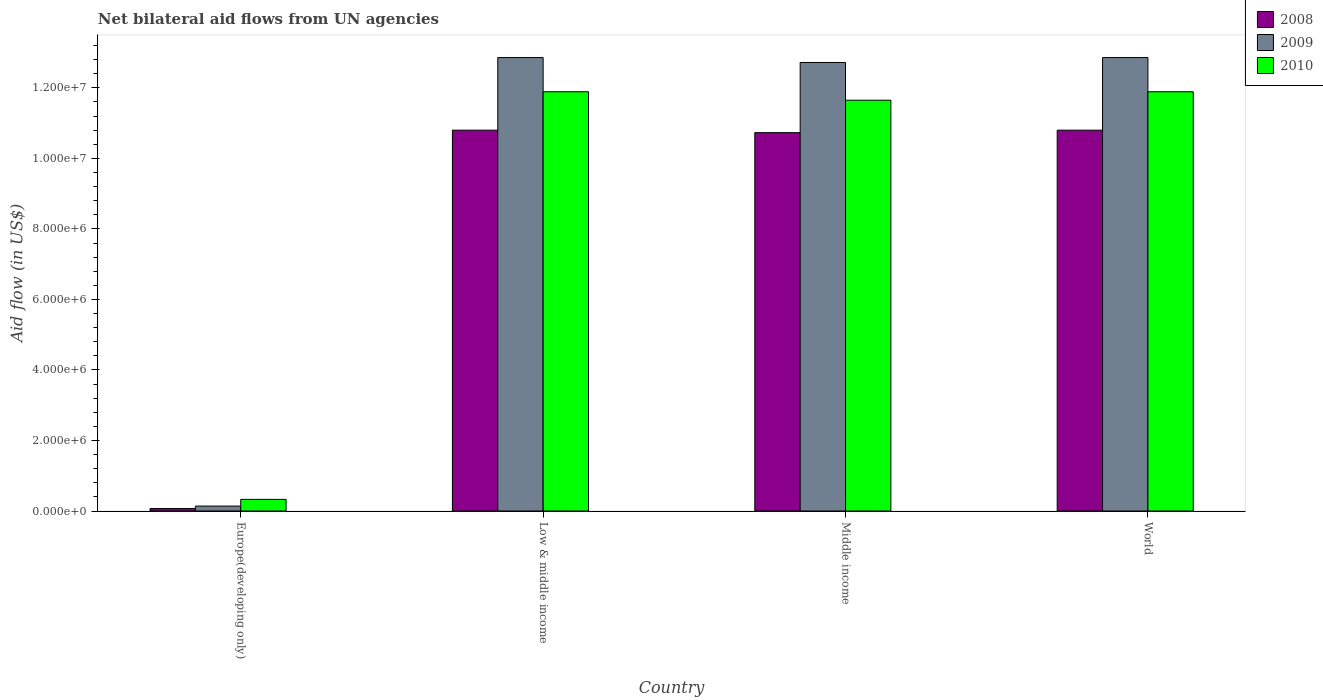How many groups of bars are there?
Your answer should be compact. 4. Are the number of bars per tick equal to the number of legend labels?
Your answer should be very brief. Yes. In how many cases, is the number of bars for a given country not equal to the number of legend labels?
Your response must be concise. 0. What is the net bilateral aid flow in 2009 in Low & middle income?
Your answer should be very brief. 1.29e+07. Across all countries, what is the maximum net bilateral aid flow in 2010?
Give a very brief answer. 1.19e+07. In which country was the net bilateral aid flow in 2008 maximum?
Provide a short and direct response. Low & middle income. In which country was the net bilateral aid flow in 2010 minimum?
Offer a very short reply. Europe(developing only). What is the total net bilateral aid flow in 2008 in the graph?
Your response must be concise. 3.24e+07. What is the difference between the net bilateral aid flow in 2009 in Europe(developing only) and that in Low & middle income?
Your answer should be very brief. -1.27e+07. What is the difference between the net bilateral aid flow in 2009 in World and the net bilateral aid flow in 2008 in Middle income?
Give a very brief answer. 2.13e+06. What is the average net bilateral aid flow in 2009 per country?
Provide a short and direct response. 9.64e+06. What is the difference between the net bilateral aid flow of/in 2009 and net bilateral aid flow of/in 2008 in Low & middle income?
Offer a very short reply. 2.06e+06. What is the ratio of the net bilateral aid flow in 2009 in Middle income to that in World?
Offer a very short reply. 0.99. Is the net bilateral aid flow in 2010 in Low & middle income less than that in Middle income?
Offer a terse response. No. What is the difference between the highest and the second highest net bilateral aid flow in 2008?
Your answer should be very brief. 7.00e+04. What is the difference between the highest and the lowest net bilateral aid flow in 2009?
Your response must be concise. 1.27e+07. In how many countries, is the net bilateral aid flow in 2009 greater than the average net bilateral aid flow in 2009 taken over all countries?
Provide a succinct answer. 3. What does the 2nd bar from the left in Europe(developing only) represents?
Offer a terse response. 2009. What does the 2nd bar from the right in Low & middle income represents?
Your response must be concise. 2009. Is it the case that in every country, the sum of the net bilateral aid flow in 2009 and net bilateral aid flow in 2008 is greater than the net bilateral aid flow in 2010?
Your answer should be very brief. No. How many bars are there?
Your answer should be compact. 12. What is the difference between two consecutive major ticks on the Y-axis?
Keep it short and to the point. 2.00e+06. Where does the legend appear in the graph?
Make the answer very short. Top right. How many legend labels are there?
Your answer should be very brief. 3. How are the legend labels stacked?
Provide a short and direct response. Vertical. What is the title of the graph?
Provide a succinct answer. Net bilateral aid flows from UN agencies. Does "1970" appear as one of the legend labels in the graph?
Give a very brief answer. No. What is the label or title of the X-axis?
Your answer should be very brief. Country. What is the label or title of the Y-axis?
Provide a succinct answer. Aid flow (in US$). What is the Aid flow (in US$) of 2008 in Low & middle income?
Offer a very short reply. 1.08e+07. What is the Aid flow (in US$) of 2009 in Low & middle income?
Offer a very short reply. 1.29e+07. What is the Aid flow (in US$) of 2010 in Low & middle income?
Ensure brevity in your answer.  1.19e+07. What is the Aid flow (in US$) of 2008 in Middle income?
Give a very brief answer. 1.07e+07. What is the Aid flow (in US$) in 2009 in Middle income?
Ensure brevity in your answer.  1.27e+07. What is the Aid flow (in US$) of 2010 in Middle income?
Make the answer very short. 1.16e+07. What is the Aid flow (in US$) of 2008 in World?
Offer a very short reply. 1.08e+07. What is the Aid flow (in US$) of 2009 in World?
Keep it short and to the point. 1.29e+07. What is the Aid flow (in US$) in 2010 in World?
Keep it short and to the point. 1.19e+07. Across all countries, what is the maximum Aid flow (in US$) in 2008?
Give a very brief answer. 1.08e+07. Across all countries, what is the maximum Aid flow (in US$) in 2009?
Give a very brief answer. 1.29e+07. Across all countries, what is the maximum Aid flow (in US$) in 2010?
Make the answer very short. 1.19e+07. Across all countries, what is the minimum Aid flow (in US$) of 2009?
Keep it short and to the point. 1.40e+05. What is the total Aid flow (in US$) in 2008 in the graph?
Ensure brevity in your answer.  3.24e+07. What is the total Aid flow (in US$) of 2009 in the graph?
Make the answer very short. 3.86e+07. What is the total Aid flow (in US$) of 2010 in the graph?
Ensure brevity in your answer.  3.58e+07. What is the difference between the Aid flow (in US$) in 2008 in Europe(developing only) and that in Low & middle income?
Your answer should be compact. -1.07e+07. What is the difference between the Aid flow (in US$) of 2009 in Europe(developing only) and that in Low & middle income?
Provide a succinct answer. -1.27e+07. What is the difference between the Aid flow (in US$) in 2010 in Europe(developing only) and that in Low & middle income?
Your answer should be compact. -1.16e+07. What is the difference between the Aid flow (in US$) in 2008 in Europe(developing only) and that in Middle income?
Ensure brevity in your answer.  -1.07e+07. What is the difference between the Aid flow (in US$) of 2009 in Europe(developing only) and that in Middle income?
Your response must be concise. -1.26e+07. What is the difference between the Aid flow (in US$) in 2010 in Europe(developing only) and that in Middle income?
Provide a short and direct response. -1.13e+07. What is the difference between the Aid flow (in US$) in 2008 in Europe(developing only) and that in World?
Give a very brief answer. -1.07e+07. What is the difference between the Aid flow (in US$) of 2009 in Europe(developing only) and that in World?
Give a very brief answer. -1.27e+07. What is the difference between the Aid flow (in US$) of 2010 in Europe(developing only) and that in World?
Provide a succinct answer. -1.16e+07. What is the difference between the Aid flow (in US$) in 2010 in Low & middle income and that in Middle income?
Offer a terse response. 2.40e+05. What is the difference between the Aid flow (in US$) of 2008 in Middle income and that in World?
Provide a succinct answer. -7.00e+04. What is the difference between the Aid flow (in US$) of 2010 in Middle income and that in World?
Keep it short and to the point. -2.40e+05. What is the difference between the Aid flow (in US$) of 2008 in Europe(developing only) and the Aid flow (in US$) of 2009 in Low & middle income?
Offer a terse response. -1.28e+07. What is the difference between the Aid flow (in US$) of 2008 in Europe(developing only) and the Aid flow (in US$) of 2010 in Low & middle income?
Provide a short and direct response. -1.18e+07. What is the difference between the Aid flow (in US$) of 2009 in Europe(developing only) and the Aid flow (in US$) of 2010 in Low & middle income?
Provide a succinct answer. -1.18e+07. What is the difference between the Aid flow (in US$) in 2008 in Europe(developing only) and the Aid flow (in US$) in 2009 in Middle income?
Provide a short and direct response. -1.26e+07. What is the difference between the Aid flow (in US$) of 2008 in Europe(developing only) and the Aid flow (in US$) of 2010 in Middle income?
Offer a very short reply. -1.16e+07. What is the difference between the Aid flow (in US$) of 2009 in Europe(developing only) and the Aid flow (in US$) of 2010 in Middle income?
Offer a very short reply. -1.15e+07. What is the difference between the Aid flow (in US$) in 2008 in Europe(developing only) and the Aid flow (in US$) in 2009 in World?
Your response must be concise. -1.28e+07. What is the difference between the Aid flow (in US$) in 2008 in Europe(developing only) and the Aid flow (in US$) in 2010 in World?
Make the answer very short. -1.18e+07. What is the difference between the Aid flow (in US$) of 2009 in Europe(developing only) and the Aid flow (in US$) of 2010 in World?
Provide a short and direct response. -1.18e+07. What is the difference between the Aid flow (in US$) in 2008 in Low & middle income and the Aid flow (in US$) in 2009 in Middle income?
Your response must be concise. -1.92e+06. What is the difference between the Aid flow (in US$) of 2008 in Low & middle income and the Aid flow (in US$) of 2010 in Middle income?
Your answer should be very brief. -8.50e+05. What is the difference between the Aid flow (in US$) of 2009 in Low & middle income and the Aid flow (in US$) of 2010 in Middle income?
Ensure brevity in your answer.  1.21e+06. What is the difference between the Aid flow (in US$) of 2008 in Low & middle income and the Aid flow (in US$) of 2009 in World?
Provide a short and direct response. -2.06e+06. What is the difference between the Aid flow (in US$) of 2008 in Low & middle income and the Aid flow (in US$) of 2010 in World?
Your response must be concise. -1.09e+06. What is the difference between the Aid flow (in US$) of 2009 in Low & middle income and the Aid flow (in US$) of 2010 in World?
Ensure brevity in your answer.  9.70e+05. What is the difference between the Aid flow (in US$) in 2008 in Middle income and the Aid flow (in US$) in 2009 in World?
Provide a succinct answer. -2.13e+06. What is the difference between the Aid flow (in US$) in 2008 in Middle income and the Aid flow (in US$) in 2010 in World?
Your answer should be compact. -1.16e+06. What is the difference between the Aid flow (in US$) of 2009 in Middle income and the Aid flow (in US$) of 2010 in World?
Provide a short and direct response. 8.30e+05. What is the average Aid flow (in US$) in 2008 per country?
Provide a short and direct response. 8.10e+06. What is the average Aid flow (in US$) in 2009 per country?
Provide a short and direct response. 9.64e+06. What is the average Aid flow (in US$) in 2010 per country?
Give a very brief answer. 8.94e+06. What is the difference between the Aid flow (in US$) in 2008 and Aid flow (in US$) in 2010 in Europe(developing only)?
Give a very brief answer. -2.60e+05. What is the difference between the Aid flow (in US$) of 2008 and Aid flow (in US$) of 2009 in Low & middle income?
Give a very brief answer. -2.06e+06. What is the difference between the Aid flow (in US$) in 2008 and Aid flow (in US$) in 2010 in Low & middle income?
Keep it short and to the point. -1.09e+06. What is the difference between the Aid flow (in US$) in 2009 and Aid flow (in US$) in 2010 in Low & middle income?
Provide a short and direct response. 9.70e+05. What is the difference between the Aid flow (in US$) of 2008 and Aid flow (in US$) of 2009 in Middle income?
Keep it short and to the point. -1.99e+06. What is the difference between the Aid flow (in US$) of 2008 and Aid flow (in US$) of 2010 in Middle income?
Give a very brief answer. -9.20e+05. What is the difference between the Aid flow (in US$) of 2009 and Aid flow (in US$) of 2010 in Middle income?
Give a very brief answer. 1.07e+06. What is the difference between the Aid flow (in US$) of 2008 and Aid flow (in US$) of 2009 in World?
Your response must be concise. -2.06e+06. What is the difference between the Aid flow (in US$) of 2008 and Aid flow (in US$) of 2010 in World?
Keep it short and to the point. -1.09e+06. What is the difference between the Aid flow (in US$) of 2009 and Aid flow (in US$) of 2010 in World?
Ensure brevity in your answer.  9.70e+05. What is the ratio of the Aid flow (in US$) of 2008 in Europe(developing only) to that in Low & middle income?
Give a very brief answer. 0.01. What is the ratio of the Aid flow (in US$) in 2009 in Europe(developing only) to that in Low & middle income?
Your answer should be compact. 0.01. What is the ratio of the Aid flow (in US$) of 2010 in Europe(developing only) to that in Low & middle income?
Provide a succinct answer. 0.03. What is the ratio of the Aid flow (in US$) in 2008 in Europe(developing only) to that in Middle income?
Provide a short and direct response. 0.01. What is the ratio of the Aid flow (in US$) of 2009 in Europe(developing only) to that in Middle income?
Provide a short and direct response. 0.01. What is the ratio of the Aid flow (in US$) in 2010 in Europe(developing only) to that in Middle income?
Give a very brief answer. 0.03. What is the ratio of the Aid flow (in US$) in 2008 in Europe(developing only) to that in World?
Your answer should be compact. 0.01. What is the ratio of the Aid flow (in US$) of 2009 in Europe(developing only) to that in World?
Offer a very short reply. 0.01. What is the ratio of the Aid flow (in US$) of 2010 in Europe(developing only) to that in World?
Make the answer very short. 0.03. What is the ratio of the Aid flow (in US$) in 2008 in Low & middle income to that in Middle income?
Provide a succinct answer. 1.01. What is the ratio of the Aid flow (in US$) in 2009 in Low & middle income to that in Middle income?
Provide a succinct answer. 1.01. What is the ratio of the Aid flow (in US$) in 2010 in Low & middle income to that in Middle income?
Offer a terse response. 1.02. What is the ratio of the Aid flow (in US$) of 2009 in Low & middle income to that in World?
Provide a succinct answer. 1. What is the ratio of the Aid flow (in US$) of 2008 in Middle income to that in World?
Your answer should be compact. 0.99. What is the ratio of the Aid flow (in US$) in 2010 in Middle income to that in World?
Your answer should be very brief. 0.98. What is the difference between the highest and the second highest Aid flow (in US$) of 2009?
Your answer should be compact. 0. What is the difference between the highest and the second highest Aid flow (in US$) in 2010?
Offer a terse response. 0. What is the difference between the highest and the lowest Aid flow (in US$) of 2008?
Your answer should be very brief. 1.07e+07. What is the difference between the highest and the lowest Aid flow (in US$) of 2009?
Make the answer very short. 1.27e+07. What is the difference between the highest and the lowest Aid flow (in US$) in 2010?
Keep it short and to the point. 1.16e+07. 